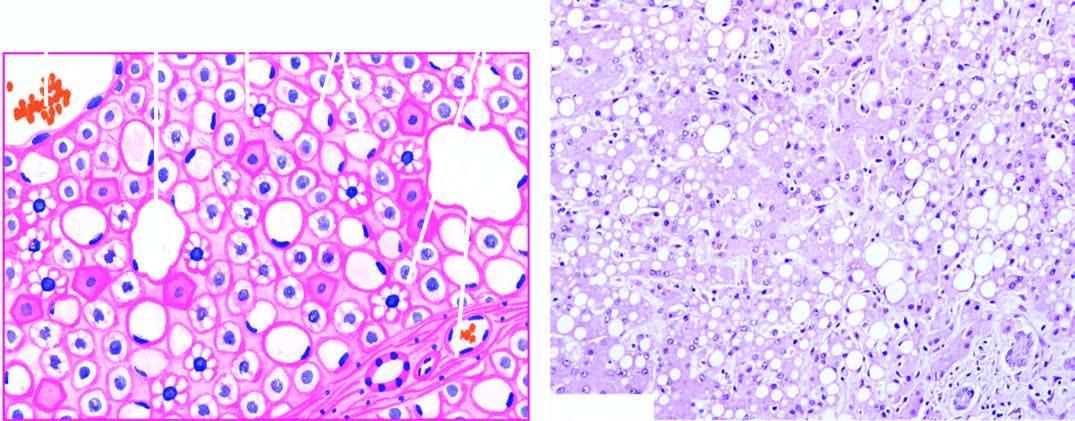re most of the hepatocytes distended with large lipid vacuoles with peripherally displaced nuclei?
Answer the question using a single word or phrase. Yes 